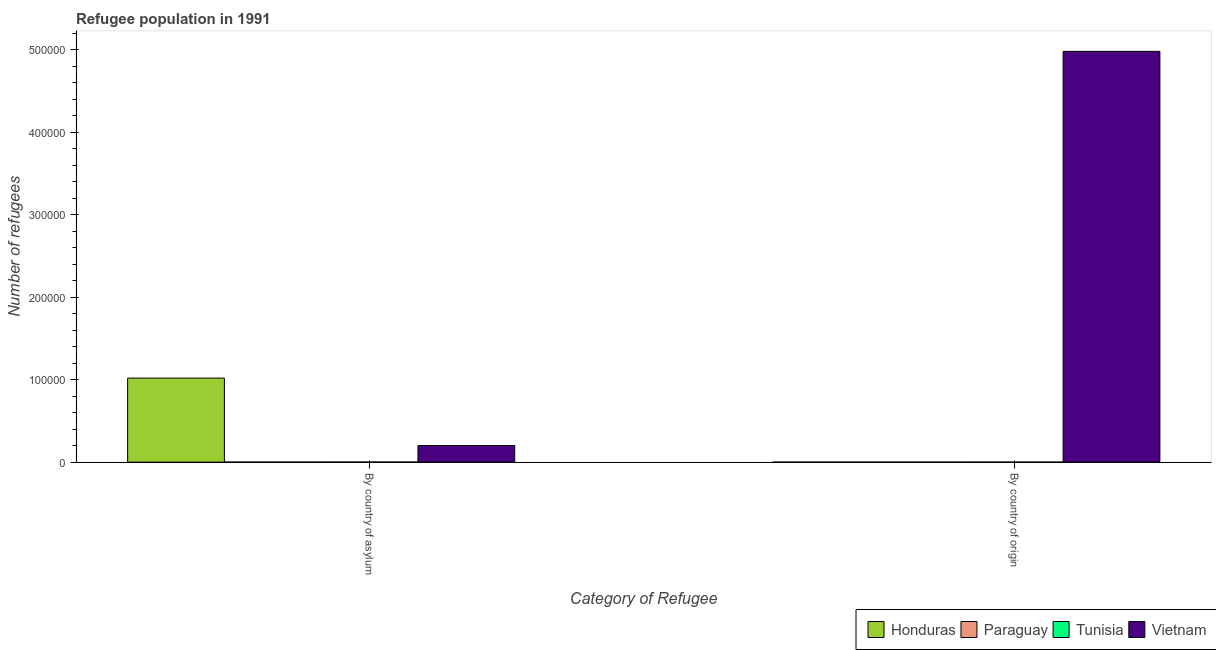How many different coloured bars are there?
Give a very brief answer. 4. Are the number of bars on each tick of the X-axis equal?
Make the answer very short. Yes. How many bars are there on the 1st tick from the right?
Your response must be concise. 4. What is the label of the 2nd group of bars from the left?
Ensure brevity in your answer.  By country of origin. What is the number of refugees by country of asylum in Tunisia?
Ensure brevity in your answer.  130. Across all countries, what is the maximum number of refugees by country of origin?
Your response must be concise. 4.98e+05. Across all countries, what is the minimum number of refugees by country of origin?
Offer a terse response. 8. In which country was the number of refugees by country of origin maximum?
Your answer should be compact. Vietnam. In which country was the number of refugees by country of origin minimum?
Your answer should be compact. Paraguay. What is the total number of refugees by country of asylum in the graph?
Your response must be concise. 1.22e+05. What is the difference between the number of refugees by country of asylum in Tunisia and that in Vietnam?
Keep it short and to the point. -2.00e+04. What is the difference between the number of refugees by country of origin in Vietnam and the number of refugees by country of asylum in Honduras?
Your answer should be very brief. 3.96e+05. What is the average number of refugees by country of asylum per country?
Ensure brevity in your answer.  3.06e+04. What is the difference between the number of refugees by country of asylum and number of refugees by country of origin in Honduras?
Make the answer very short. 1.02e+05. What is the ratio of the number of refugees by country of origin in Vietnam to that in Paraguay?
Keep it short and to the point. 6.23e+04. In how many countries, is the number of refugees by country of origin greater than the average number of refugees by country of origin taken over all countries?
Your answer should be very brief. 1. What does the 2nd bar from the left in By country of asylum represents?
Ensure brevity in your answer.  Paraguay. What does the 4th bar from the right in By country of asylum represents?
Provide a succinct answer. Honduras. How many bars are there?
Keep it short and to the point. 8. What is the title of the graph?
Your answer should be compact. Refugee population in 1991. Does "Oman" appear as one of the legend labels in the graph?
Your response must be concise. No. What is the label or title of the X-axis?
Offer a very short reply. Category of Refugee. What is the label or title of the Y-axis?
Give a very brief answer. Number of refugees. What is the Number of refugees in Honduras in By country of asylum?
Your answer should be very brief. 1.02e+05. What is the Number of refugees in Tunisia in By country of asylum?
Make the answer very short. 130. What is the Number of refugees in Vietnam in By country of asylum?
Your response must be concise. 2.01e+04. What is the Number of refugees in Vietnam in By country of origin?
Give a very brief answer. 4.98e+05. Across all Category of Refugee, what is the maximum Number of refugees in Honduras?
Provide a short and direct response. 1.02e+05. Across all Category of Refugee, what is the maximum Number of refugees in Tunisia?
Offer a very short reply. 130. Across all Category of Refugee, what is the maximum Number of refugees of Vietnam?
Offer a terse response. 4.98e+05. Across all Category of Refugee, what is the minimum Number of refugees of Honduras?
Your answer should be compact. 21. Across all Category of Refugee, what is the minimum Number of refugees in Vietnam?
Offer a very short reply. 2.01e+04. What is the total Number of refugees of Honduras in the graph?
Your response must be concise. 1.02e+05. What is the total Number of refugees in Tunisia in the graph?
Your response must be concise. 193. What is the total Number of refugees of Vietnam in the graph?
Keep it short and to the point. 5.18e+05. What is the difference between the Number of refugees in Honduras in By country of asylum and that in By country of origin?
Keep it short and to the point. 1.02e+05. What is the difference between the Number of refugees in Paraguay in By country of asylum and that in By country of origin?
Give a very brief answer. 58. What is the difference between the Number of refugees of Tunisia in By country of asylum and that in By country of origin?
Provide a succinct answer. 67. What is the difference between the Number of refugees in Vietnam in By country of asylum and that in By country of origin?
Offer a very short reply. -4.78e+05. What is the difference between the Number of refugees of Honduras in By country of asylum and the Number of refugees of Paraguay in By country of origin?
Offer a terse response. 1.02e+05. What is the difference between the Number of refugees of Honduras in By country of asylum and the Number of refugees of Tunisia in By country of origin?
Give a very brief answer. 1.02e+05. What is the difference between the Number of refugees of Honduras in By country of asylum and the Number of refugees of Vietnam in By country of origin?
Your response must be concise. -3.96e+05. What is the difference between the Number of refugees in Paraguay in By country of asylum and the Number of refugees in Tunisia in By country of origin?
Offer a terse response. 3. What is the difference between the Number of refugees of Paraguay in By country of asylum and the Number of refugees of Vietnam in By country of origin?
Provide a succinct answer. -4.98e+05. What is the difference between the Number of refugees in Tunisia in By country of asylum and the Number of refugees in Vietnam in By country of origin?
Offer a very short reply. -4.98e+05. What is the average Number of refugees of Honduras per Category of Refugee?
Offer a very short reply. 5.10e+04. What is the average Number of refugees in Tunisia per Category of Refugee?
Provide a succinct answer. 96.5. What is the average Number of refugees of Vietnam per Category of Refugee?
Make the answer very short. 2.59e+05. What is the difference between the Number of refugees of Honduras and Number of refugees of Paraguay in By country of asylum?
Your answer should be compact. 1.02e+05. What is the difference between the Number of refugees of Honduras and Number of refugees of Tunisia in By country of asylum?
Your answer should be compact. 1.02e+05. What is the difference between the Number of refugees in Honduras and Number of refugees in Vietnam in By country of asylum?
Ensure brevity in your answer.  8.18e+04. What is the difference between the Number of refugees in Paraguay and Number of refugees in Tunisia in By country of asylum?
Offer a terse response. -64. What is the difference between the Number of refugees of Paraguay and Number of refugees of Vietnam in By country of asylum?
Your answer should be compact. -2.01e+04. What is the difference between the Number of refugees in Tunisia and Number of refugees in Vietnam in By country of asylum?
Your answer should be compact. -2.00e+04. What is the difference between the Number of refugees of Honduras and Number of refugees of Tunisia in By country of origin?
Keep it short and to the point. -42. What is the difference between the Number of refugees of Honduras and Number of refugees of Vietnam in By country of origin?
Provide a succinct answer. -4.98e+05. What is the difference between the Number of refugees of Paraguay and Number of refugees of Tunisia in By country of origin?
Provide a short and direct response. -55. What is the difference between the Number of refugees in Paraguay and Number of refugees in Vietnam in By country of origin?
Make the answer very short. -4.98e+05. What is the difference between the Number of refugees in Tunisia and Number of refugees in Vietnam in By country of origin?
Keep it short and to the point. -4.98e+05. What is the ratio of the Number of refugees of Honduras in By country of asylum to that in By country of origin?
Make the answer very short. 4855.29. What is the ratio of the Number of refugees in Paraguay in By country of asylum to that in By country of origin?
Offer a terse response. 8.25. What is the ratio of the Number of refugees of Tunisia in By country of asylum to that in By country of origin?
Give a very brief answer. 2.06. What is the ratio of the Number of refugees of Vietnam in By country of asylum to that in By country of origin?
Offer a very short reply. 0.04. What is the difference between the highest and the second highest Number of refugees of Honduras?
Your answer should be compact. 1.02e+05. What is the difference between the highest and the second highest Number of refugees in Tunisia?
Your response must be concise. 67. What is the difference between the highest and the second highest Number of refugees in Vietnam?
Offer a very short reply. 4.78e+05. What is the difference between the highest and the lowest Number of refugees of Honduras?
Your response must be concise. 1.02e+05. What is the difference between the highest and the lowest Number of refugees of Paraguay?
Offer a very short reply. 58. What is the difference between the highest and the lowest Number of refugees in Tunisia?
Keep it short and to the point. 67. What is the difference between the highest and the lowest Number of refugees in Vietnam?
Your answer should be very brief. 4.78e+05. 